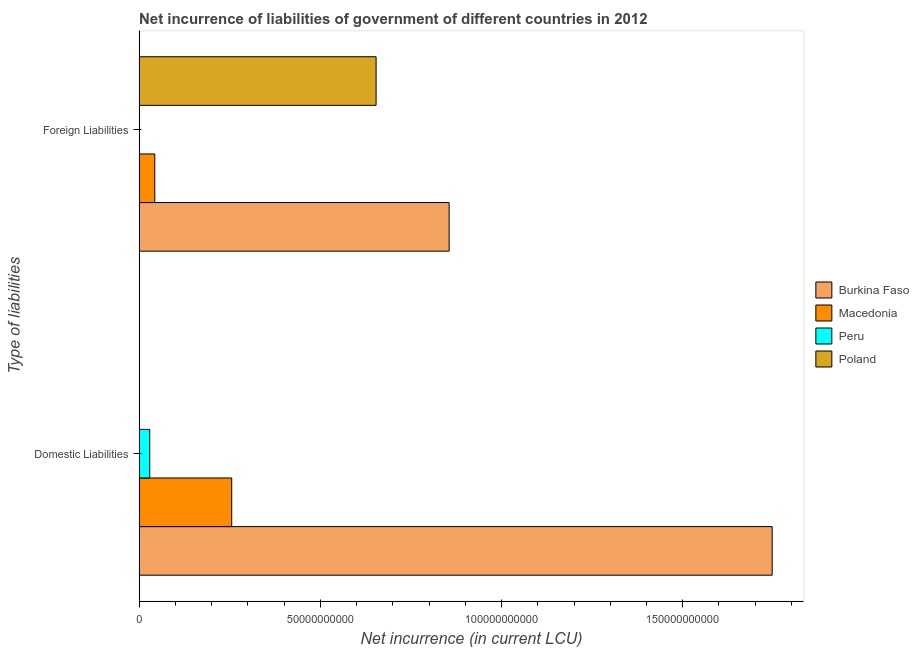How many different coloured bars are there?
Keep it short and to the point. 4. How many bars are there on the 2nd tick from the bottom?
Provide a succinct answer. 3. What is the label of the 2nd group of bars from the top?
Provide a short and direct response. Domestic Liabilities. What is the net incurrence of domestic liabilities in Burkina Faso?
Keep it short and to the point. 1.75e+11. Across all countries, what is the maximum net incurrence of foreign liabilities?
Your answer should be very brief. 8.55e+1. In which country was the net incurrence of domestic liabilities maximum?
Keep it short and to the point. Burkina Faso. What is the total net incurrence of foreign liabilities in the graph?
Give a very brief answer. 1.55e+11. What is the difference between the net incurrence of foreign liabilities in Burkina Faso and that in Poland?
Your response must be concise. 2.02e+1. What is the difference between the net incurrence of domestic liabilities in Macedonia and the net incurrence of foreign liabilities in Burkina Faso?
Provide a succinct answer. -6.00e+1. What is the average net incurrence of foreign liabilities per country?
Your answer should be compact. 3.88e+1. What is the difference between the net incurrence of foreign liabilities and net incurrence of domestic liabilities in Burkina Faso?
Give a very brief answer. -8.91e+1. What is the ratio of the net incurrence of domestic liabilities in Peru to that in Macedonia?
Your answer should be compact. 0.11. In how many countries, is the net incurrence of foreign liabilities greater than the average net incurrence of foreign liabilities taken over all countries?
Keep it short and to the point. 2. How many countries are there in the graph?
Make the answer very short. 4. Are the values on the major ticks of X-axis written in scientific E-notation?
Ensure brevity in your answer.  No. Does the graph contain any zero values?
Keep it short and to the point. Yes. Where does the legend appear in the graph?
Make the answer very short. Center right. How many legend labels are there?
Your answer should be very brief. 4. How are the legend labels stacked?
Keep it short and to the point. Vertical. What is the title of the graph?
Your answer should be compact. Net incurrence of liabilities of government of different countries in 2012. What is the label or title of the X-axis?
Ensure brevity in your answer.  Net incurrence (in current LCU). What is the label or title of the Y-axis?
Ensure brevity in your answer.  Type of liabilities. What is the Net incurrence (in current LCU) in Burkina Faso in Domestic Liabilities?
Your answer should be very brief. 1.75e+11. What is the Net incurrence (in current LCU) of Macedonia in Domestic Liabilities?
Provide a short and direct response. 2.56e+1. What is the Net incurrence (in current LCU) of Peru in Domestic Liabilities?
Your response must be concise. 2.94e+09. What is the Net incurrence (in current LCU) in Poland in Domestic Liabilities?
Offer a terse response. 0. What is the Net incurrence (in current LCU) of Burkina Faso in Foreign Liabilities?
Provide a succinct answer. 8.55e+1. What is the Net incurrence (in current LCU) of Macedonia in Foreign Liabilities?
Offer a very short reply. 4.32e+09. What is the Net incurrence (in current LCU) in Poland in Foreign Liabilities?
Give a very brief answer. 6.54e+1. Across all Type of liabilities, what is the maximum Net incurrence (in current LCU) of Burkina Faso?
Offer a very short reply. 1.75e+11. Across all Type of liabilities, what is the maximum Net incurrence (in current LCU) of Macedonia?
Your response must be concise. 2.56e+1. Across all Type of liabilities, what is the maximum Net incurrence (in current LCU) of Peru?
Offer a terse response. 2.94e+09. Across all Type of liabilities, what is the maximum Net incurrence (in current LCU) of Poland?
Your response must be concise. 6.54e+1. Across all Type of liabilities, what is the minimum Net incurrence (in current LCU) in Burkina Faso?
Offer a very short reply. 8.55e+1. Across all Type of liabilities, what is the minimum Net incurrence (in current LCU) in Macedonia?
Offer a very short reply. 4.32e+09. What is the total Net incurrence (in current LCU) in Burkina Faso in the graph?
Make the answer very short. 2.60e+11. What is the total Net incurrence (in current LCU) in Macedonia in the graph?
Keep it short and to the point. 2.99e+1. What is the total Net incurrence (in current LCU) in Peru in the graph?
Ensure brevity in your answer.  2.94e+09. What is the total Net incurrence (in current LCU) in Poland in the graph?
Your answer should be compact. 6.54e+1. What is the difference between the Net incurrence (in current LCU) in Burkina Faso in Domestic Liabilities and that in Foreign Liabilities?
Offer a terse response. 8.91e+1. What is the difference between the Net incurrence (in current LCU) in Macedonia in Domestic Liabilities and that in Foreign Liabilities?
Make the answer very short. 2.12e+1. What is the difference between the Net incurrence (in current LCU) in Burkina Faso in Domestic Liabilities and the Net incurrence (in current LCU) in Macedonia in Foreign Liabilities?
Your response must be concise. 1.70e+11. What is the difference between the Net incurrence (in current LCU) in Burkina Faso in Domestic Liabilities and the Net incurrence (in current LCU) in Poland in Foreign Liabilities?
Make the answer very short. 1.09e+11. What is the difference between the Net incurrence (in current LCU) of Macedonia in Domestic Liabilities and the Net incurrence (in current LCU) of Poland in Foreign Liabilities?
Your response must be concise. -3.98e+1. What is the difference between the Net incurrence (in current LCU) in Peru in Domestic Liabilities and the Net incurrence (in current LCU) in Poland in Foreign Liabilities?
Offer a terse response. -6.25e+1. What is the average Net incurrence (in current LCU) of Burkina Faso per Type of liabilities?
Offer a terse response. 1.30e+11. What is the average Net incurrence (in current LCU) of Macedonia per Type of liabilities?
Offer a very short reply. 1.49e+1. What is the average Net incurrence (in current LCU) of Peru per Type of liabilities?
Keep it short and to the point. 1.47e+09. What is the average Net incurrence (in current LCU) in Poland per Type of liabilities?
Offer a terse response. 3.27e+1. What is the difference between the Net incurrence (in current LCU) of Burkina Faso and Net incurrence (in current LCU) of Macedonia in Domestic Liabilities?
Provide a succinct answer. 1.49e+11. What is the difference between the Net incurrence (in current LCU) in Burkina Faso and Net incurrence (in current LCU) in Peru in Domestic Liabilities?
Your answer should be compact. 1.72e+11. What is the difference between the Net incurrence (in current LCU) in Macedonia and Net incurrence (in current LCU) in Peru in Domestic Liabilities?
Keep it short and to the point. 2.26e+1. What is the difference between the Net incurrence (in current LCU) of Burkina Faso and Net incurrence (in current LCU) of Macedonia in Foreign Liabilities?
Give a very brief answer. 8.12e+1. What is the difference between the Net incurrence (in current LCU) in Burkina Faso and Net incurrence (in current LCU) in Poland in Foreign Liabilities?
Provide a succinct answer. 2.02e+1. What is the difference between the Net incurrence (in current LCU) of Macedonia and Net incurrence (in current LCU) of Poland in Foreign Liabilities?
Provide a short and direct response. -6.11e+1. What is the ratio of the Net incurrence (in current LCU) of Burkina Faso in Domestic Liabilities to that in Foreign Liabilities?
Provide a succinct answer. 2.04. What is the ratio of the Net incurrence (in current LCU) in Macedonia in Domestic Liabilities to that in Foreign Liabilities?
Your answer should be compact. 5.91. What is the difference between the highest and the second highest Net incurrence (in current LCU) in Burkina Faso?
Your answer should be compact. 8.91e+1. What is the difference between the highest and the second highest Net incurrence (in current LCU) of Macedonia?
Your response must be concise. 2.12e+1. What is the difference between the highest and the lowest Net incurrence (in current LCU) in Burkina Faso?
Make the answer very short. 8.91e+1. What is the difference between the highest and the lowest Net incurrence (in current LCU) in Macedonia?
Keep it short and to the point. 2.12e+1. What is the difference between the highest and the lowest Net incurrence (in current LCU) of Peru?
Ensure brevity in your answer.  2.94e+09. What is the difference between the highest and the lowest Net incurrence (in current LCU) in Poland?
Provide a succinct answer. 6.54e+1. 